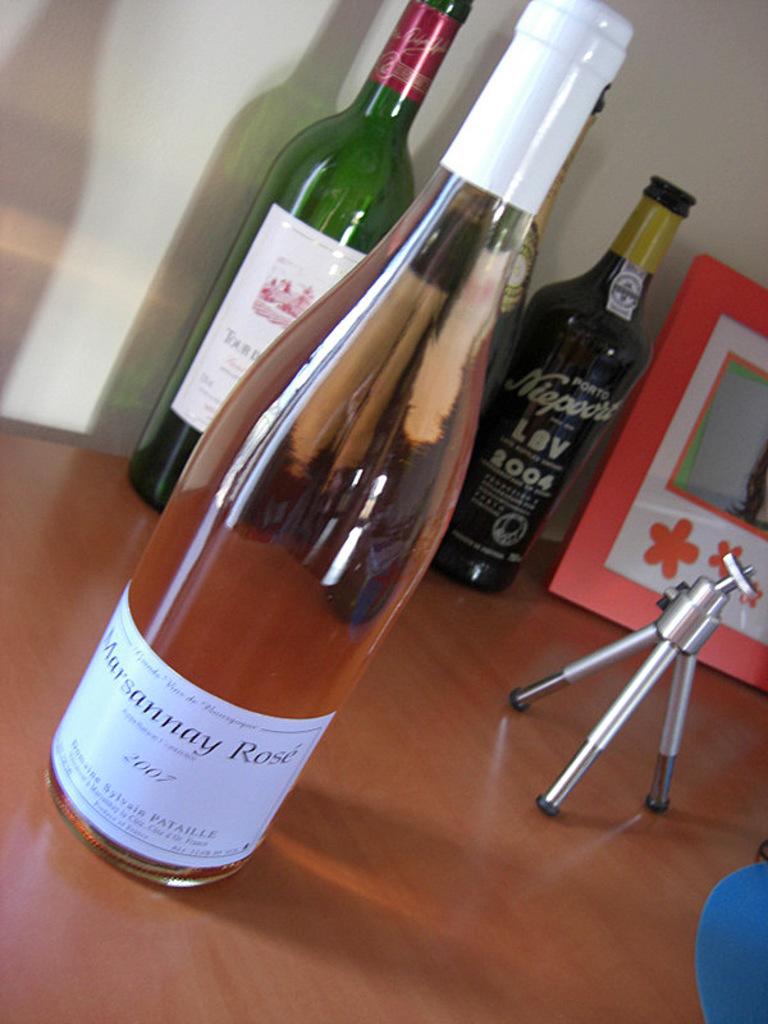What year is the bottle in the back right?
Ensure brevity in your answer.  2004. 